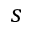<formula> <loc_0><loc_0><loc_500><loc_500>s</formula> 